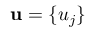<formula> <loc_0><loc_0><loc_500><loc_500>u = \{ u _ { j } \}</formula> 